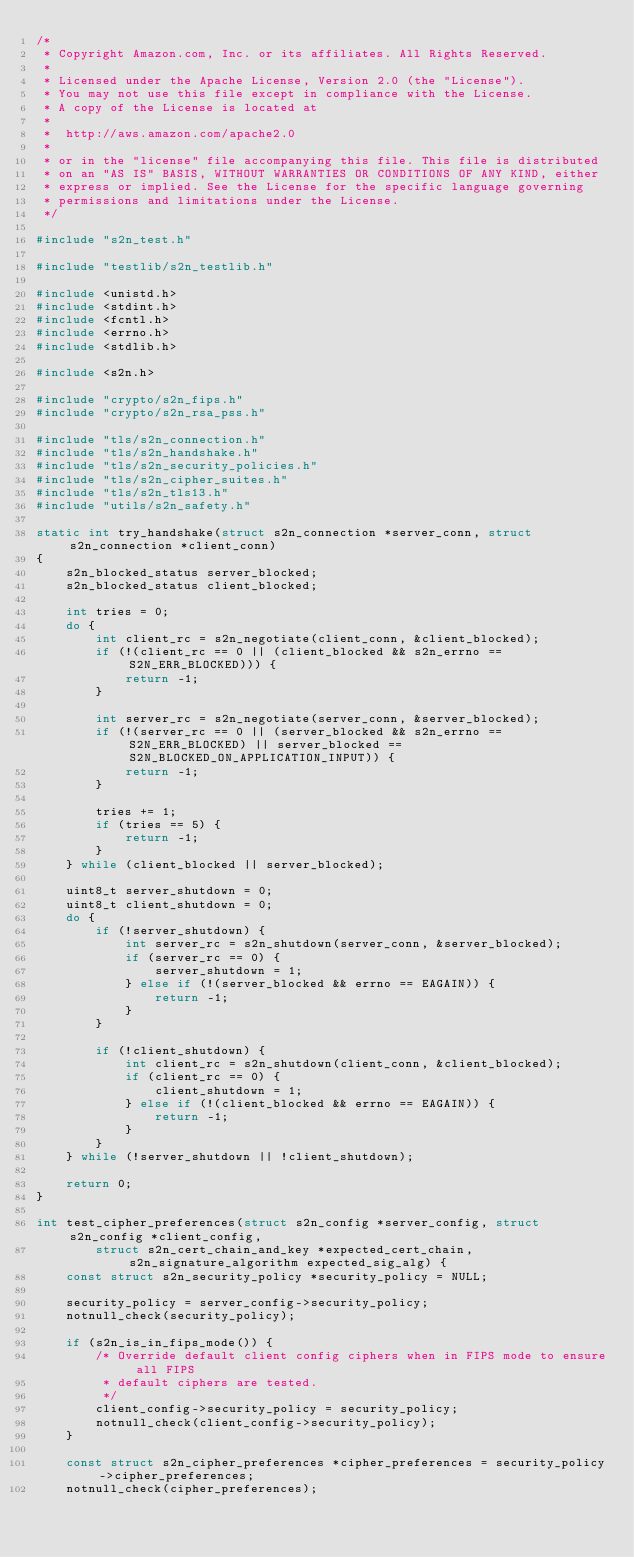<code> <loc_0><loc_0><loc_500><loc_500><_C_>/*
 * Copyright Amazon.com, Inc. or its affiliates. All Rights Reserved.
 *
 * Licensed under the Apache License, Version 2.0 (the "License").
 * You may not use this file except in compliance with the License.
 * A copy of the License is located at
 *
 *  http://aws.amazon.com/apache2.0
 *
 * or in the "license" file accompanying this file. This file is distributed
 * on an "AS IS" BASIS, WITHOUT WARRANTIES OR CONDITIONS OF ANY KIND, either
 * express or implied. See the License for the specific language governing
 * permissions and limitations under the License.
 */

#include "s2n_test.h"

#include "testlib/s2n_testlib.h"

#include <unistd.h>
#include <stdint.h>
#include <fcntl.h>
#include <errno.h>
#include <stdlib.h>

#include <s2n.h>

#include "crypto/s2n_fips.h"
#include "crypto/s2n_rsa_pss.h"

#include "tls/s2n_connection.h"
#include "tls/s2n_handshake.h"
#include "tls/s2n_security_policies.h"
#include "tls/s2n_cipher_suites.h"
#include "tls/s2n_tls13.h"
#include "utils/s2n_safety.h"

static int try_handshake(struct s2n_connection *server_conn, struct s2n_connection *client_conn)
{
    s2n_blocked_status server_blocked;
    s2n_blocked_status client_blocked;

    int tries = 0;
    do {
        int client_rc = s2n_negotiate(client_conn, &client_blocked);
        if (!(client_rc == 0 || (client_blocked && s2n_errno == S2N_ERR_BLOCKED))) {
            return -1;
        }

        int server_rc = s2n_negotiate(server_conn, &server_blocked);
        if (!(server_rc == 0 || (server_blocked && s2n_errno == S2N_ERR_BLOCKED) || server_blocked == S2N_BLOCKED_ON_APPLICATION_INPUT)) {
            return -1;
        }

        tries += 1;
        if (tries == 5) {
            return -1;
        }
    } while (client_blocked || server_blocked);

    uint8_t server_shutdown = 0;
    uint8_t client_shutdown = 0;
    do {
        if (!server_shutdown) {
            int server_rc = s2n_shutdown(server_conn, &server_blocked);
            if (server_rc == 0) {
                server_shutdown = 1;
            } else if (!(server_blocked && errno == EAGAIN)) {
                return -1;
            }
        }

        if (!client_shutdown) {
            int client_rc = s2n_shutdown(client_conn, &client_blocked);
            if (client_rc == 0) {
                client_shutdown = 1;
            } else if (!(client_blocked && errno == EAGAIN)) {
                return -1;
            }
        }
    } while (!server_shutdown || !client_shutdown);

    return 0;
}

int test_cipher_preferences(struct s2n_config *server_config, struct s2n_config *client_config,
        struct s2n_cert_chain_and_key *expected_cert_chain, s2n_signature_algorithm expected_sig_alg) {
    const struct s2n_security_policy *security_policy = NULL;

    security_policy = server_config->security_policy;
    notnull_check(security_policy);

    if (s2n_is_in_fips_mode()) {
        /* Override default client config ciphers when in FIPS mode to ensure all FIPS
         * default ciphers are tested.
         */
        client_config->security_policy = security_policy;
        notnull_check(client_config->security_policy);
    }

    const struct s2n_cipher_preferences *cipher_preferences = security_policy->cipher_preferences;
    notnull_check(cipher_preferences);
</code> 